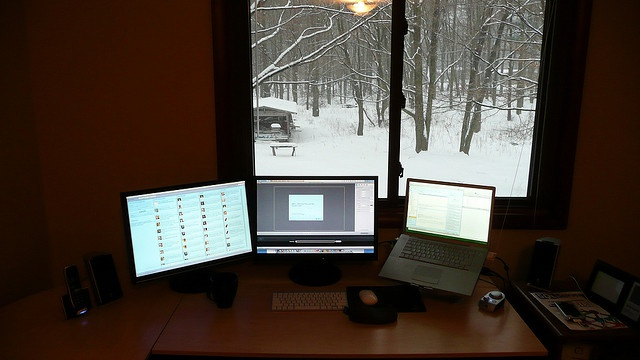Describe the objects in this image and their specific colors. I can see laptop in black, lightgray, and gray tones, laptop in black, ivory, gray, and maroon tones, keyboard in black, darkgreen, and gray tones, keyboard in black and maroon tones, and cell phone in black, gray, and maroon tones in this image. 